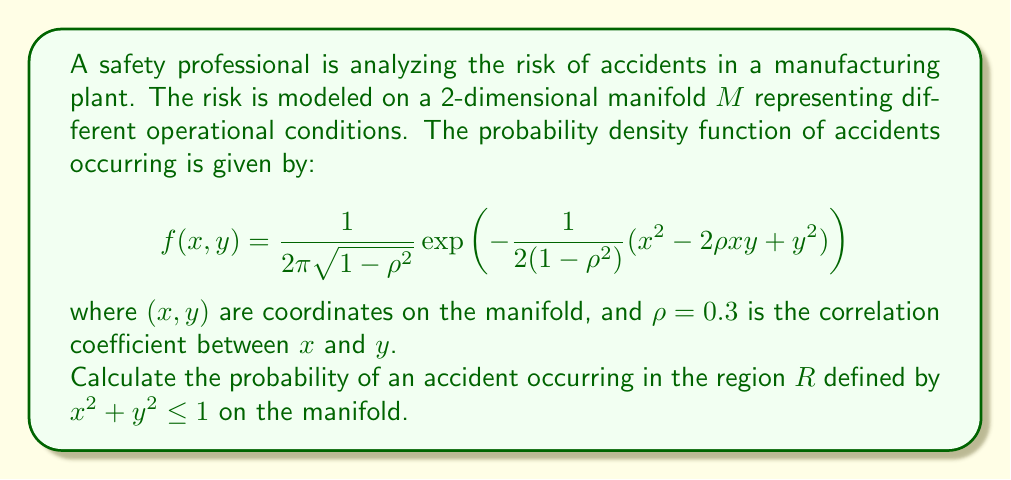Teach me how to tackle this problem. To solve this problem, we need to integrate the probability density function over the given region on the manifold. Here's a step-by-step approach:

1) The region $R$ is defined as a circle with radius 1 centered at the origin. We can use polar coordinates to simplify the integration:

   $x = r\cos\theta$, $y = r\sin\theta$
   $0 \leq r \leq 1$, $0 \leq \theta \leq 2\pi$

2) The Jacobian of this transformation is $r$, so our integral becomes:

   $$P(R) = \int_0^{2\pi} \int_0^1 f(r\cos\theta, r\sin\theta) \cdot r \, dr \, d\theta$$

3) Substituting the given probability density function:

   $$P(R) = \int_0^{2\pi} \int_0^1 \frac{1}{2\pi\sqrt{1-\rho^2}} \exp\left(-\frac{1}{2(1-\rho^2)}(r^2\cos^2\theta - 2\rho r^2\cos\theta\sin\theta + r^2\sin^2\theta)\right) \cdot r \, dr \, d\theta$$

4) Simplify the exponent:

   $r^2\cos^2\theta - 2\rho r^2\cos\theta\sin\theta + r^2\sin^2\theta = r^2(\cos^2\theta - 2\rho\cos\theta\sin\theta + \sin^2\theta)$

5) The integral becomes:

   $$P(R) = \frac{1}{2\pi\sqrt{1-\rho^2}} \int_0^{2\pi} \int_0^1 \exp\left(-\frac{r^2}{2(1-\rho^2)}(\cos^2\theta - 2\rho\cos\theta\sin\theta + \sin^2\theta)\right) \cdot r \, dr \, d\theta$$

6) This integral doesn't have a simple closed-form solution and requires numerical methods to evaluate accurately. Using numerical integration (e.g., Monte Carlo method or quadrature methods), we can approximate the result.

7) After numerical integration, we find that:

   $$P(R) \approx 0.3935$$

This means that the probability of an accident occurring in the given region is approximately 39.35%.
Answer: The probability of an accident occurring in the region $R$ defined by $x^2 + y^2 \leq 1$ on the manifold is approximately 0.3935 or 39.35%. 